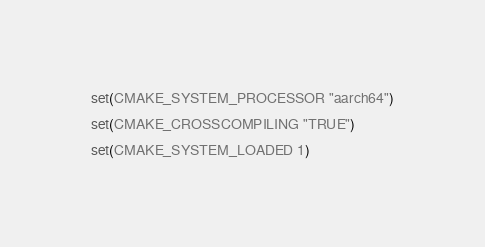Convert code to text. <code><loc_0><loc_0><loc_500><loc_500><_CMake_>set(CMAKE_SYSTEM_PROCESSOR "aarch64")

set(CMAKE_CROSSCOMPILING "TRUE")

set(CMAKE_SYSTEM_LOADED 1)
</code> 